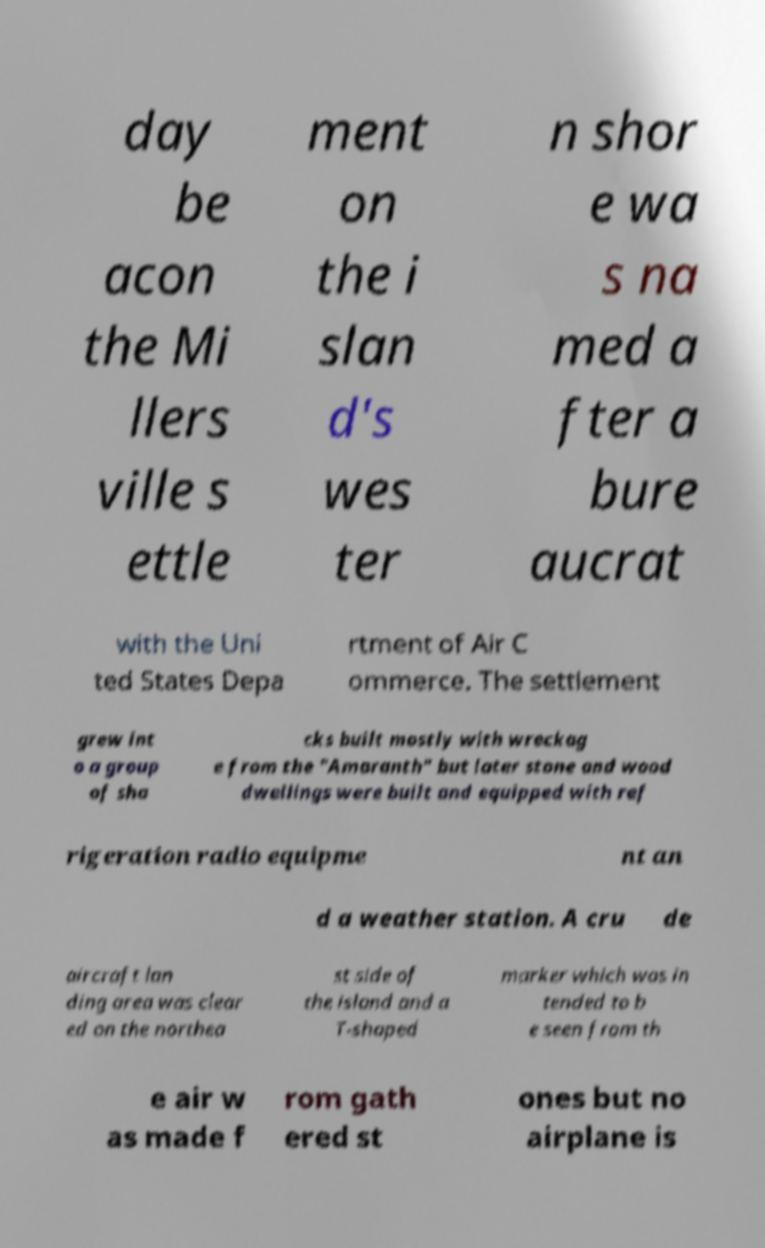Please identify and transcribe the text found in this image. day be acon the Mi llers ville s ettle ment on the i slan d's wes ter n shor e wa s na med a fter a bure aucrat with the Uni ted States Depa rtment of Air C ommerce. The settlement grew int o a group of sha cks built mostly with wreckag e from the "Amaranth" but later stone and wood dwellings were built and equipped with ref rigeration radio equipme nt an d a weather station. A cru de aircraft lan ding area was clear ed on the northea st side of the island and a T-shaped marker which was in tended to b e seen from th e air w as made f rom gath ered st ones but no airplane is 